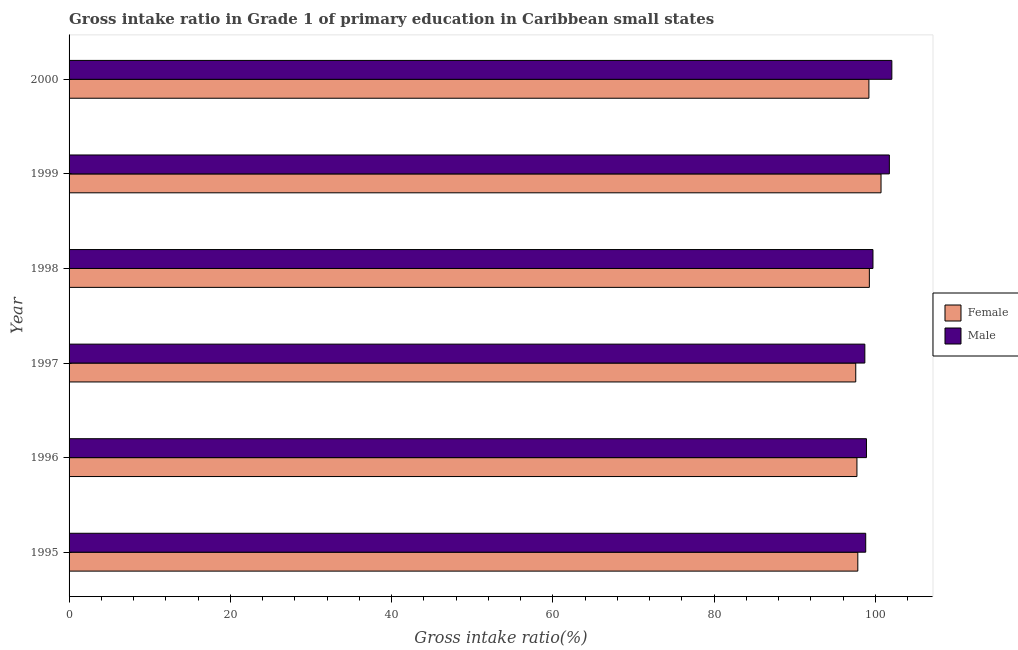How many different coloured bars are there?
Keep it short and to the point. 2. Are the number of bars per tick equal to the number of legend labels?
Ensure brevity in your answer.  Yes. Are the number of bars on each tick of the Y-axis equal?
Ensure brevity in your answer.  Yes. How many bars are there on the 4th tick from the bottom?
Keep it short and to the point. 2. What is the gross intake ratio(female) in 1999?
Make the answer very short. 100.7. Across all years, what is the maximum gross intake ratio(female)?
Your answer should be compact. 100.7. Across all years, what is the minimum gross intake ratio(male)?
Keep it short and to the point. 98.69. What is the total gross intake ratio(female) in the graph?
Make the answer very short. 592.22. What is the difference between the gross intake ratio(female) in 1995 and that in 1999?
Provide a short and direct response. -2.88. What is the difference between the gross intake ratio(female) in 2000 and the gross intake ratio(male) in 1996?
Your answer should be compact. 0.3. What is the average gross intake ratio(male) per year?
Offer a terse response. 99.97. In the year 1999, what is the difference between the gross intake ratio(male) and gross intake ratio(female)?
Make the answer very short. 1.03. What is the ratio of the gross intake ratio(female) in 1996 to that in 2000?
Offer a terse response. 0.98. Is the gross intake ratio(male) in 1995 less than that in 2000?
Offer a very short reply. Yes. Is the difference between the gross intake ratio(female) in 1995 and 1999 greater than the difference between the gross intake ratio(male) in 1995 and 1999?
Provide a succinct answer. Yes. What is the difference between the highest and the second highest gross intake ratio(female)?
Your answer should be compact. 1.45. What is the difference between the highest and the lowest gross intake ratio(female)?
Your answer should be compact. 3.14. In how many years, is the gross intake ratio(female) greater than the average gross intake ratio(female) taken over all years?
Make the answer very short. 3. What does the 2nd bar from the top in 2000 represents?
Your answer should be compact. Female. How many years are there in the graph?
Offer a terse response. 6. What is the difference between two consecutive major ticks on the X-axis?
Offer a very short reply. 20. Does the graph contain any zero values?
Ensure brevity in your answer.  No. Does the graph contain grids?
Provide a succinct answer. No. How are the legend labels stacked?
Offer a very short reply. Vertical. What is the title of the graph?
Provide a short and direct response. Gross intake ratio in Grade 1 of primary education in Caribbean small states. Does "Arms imports" appear as one of the legend labels in the graph?
Offer a very short reply. No. What is the label or title of the X-axis?
Give a very brief answer. Gross intake ratio(%). What is the Gross intake ratio(%) in Female in 1995?
Offer a terse response. 97.82. What is the Gross intake ratio(%) of Male in 1995?
Keep it short and to the point. 98.8. What is the Gross intake ratio(%) of Female in 1996?
Provide a succinct answer. 97.71. What is the Gross intake ratio(%) of Male in 1996?
Give a very brief answer. 98.89. What is the Gross intake ratio(%) of Female in 1997?
Give a very brief answer. 97.56. What is the Gross intake ratio(%) in Male in 1997?
Give a very brief answer. 98.69. What is the Gross intake ratio(%) in Female in 1998?
Keep it short and to the point. 99.25. What is the Gross intake ratio(%) of Male in 1998?
Offer a very short reply. 99.7. What is the Gross intake ratio(%) in Female in 1999?
Offer a terse response. 100.7. What is the Gross intake ratio(%) in Male in 1999?
Offer a very short reply. 101.73. What is the Gross intake ratio(%) of Female in 2000?
Offer a terse response. 99.19. What is the Gross intake ratio(%) of Male in 2000?
Your answer should be compact. 102.04. Across all years, what is the maximum Gross intake ratio(%) of Female?
Your answer should be compact. 100.7. Across all years, what is the maximum Gross intake ratio(%) of Male?
Offer a very short reply. 102.04. Across all years, what is the minimum Gross intake ratio(%) in Female?
Ensure brevity in your answer.  97.56. Across all years, what is the minimum Gross intake ratio(%) in Male?
Offer a very short reply. 98.69. What is the total Gross intake ratio(%) of Female in the graph?
Offer a very short reply. 592.22. What is the total Gross intake ratio(%) in Male in the graph?
Provide a short and direct response. 599.83. What is the difference between the Gross intake ratio(%) of Female in 1995 and that in 1996?
Ensure brevity in your answer.  0.11. What is the difference between the Gross intake ratio(%) in Male in 1995 and that in 1996?
Give a very brief answer. -0.09. What is the difference between the Gross intake ratio(%) of Female in 1995 and that in 1997?
Make the answer very short. 0.26. What is the difference between the Gross intake ratio(%) in Male in 1995 and that in 1997?
Offer a terse response. 0.11. What is the difference between the Gross intake ratio(%) in Female in 1995 and that in 1998?
Ensure brevity in your answer.  -1.43. What is the difference between the Gross intake ratio(%) of Male in 1995 and that in 1998?
Make the answer very short. -0.9. What is the difference between the Gross intake ratio(%) in Female in 1995 and that in 1999?
Make the answer very short. -2.88. What is the difference between the Gross intake ratio(%) in Male in 1995 and that in 1999?
Your answer should be very brief. -2.93. What is the difference between the Gross intake ratio(%) of Female in 1995 and that in 2000?
Ensure brevity in your answer.  -1.38. What is the difference between the Gross intake ratio(%) in Male in 1995 and that in 2000?
Keep it short and to the point. -3.24. What is the difference between the Gross intake ratio(%) in Female in 1996 and that in 1997?
Offer a terse response. 0.15. What is the difference between the Gross intake ratio(%) of Male in 1996 and that in 1997?
Ensure brevity in your answer.  0.2. What is the difference between the Gross intake ratio(%) of Female in 1996 and that in 1998?
Your response must be concise. -1.54. What is the difference between the Gross intake ratio(%) of Male in 1996 and that in 1998?
Provide a succinct answer. -0.81. What is the difference between the Gross intake ratio(%) of Female in 1996 and that in 1999?
Make the answer very short. -2.99. What is the difference between the Gross intake ratio(%) in Male in 1996 and that in 1999?
Your answer should be compact. -2.84. What is the difference between the Gross intake ratio(%) of Female in 1996 and that in 2000?
Your answer should be very brief. -1.48. What is the difference between the Gross intake ratio(%) of Male in 1996 and that in 2000?
Provide a short and direct response. -3.15. What is the difference between the Gross intake ratio(%) of Female in 1997 and that in 1998?
Give a very brief answer. -1.69. What is the difference between the Gross intake ratio(%) of Male in 1997 and that in 1998?
Your answer should be very brief. -1.01. What is the difference between the Gross intake ratio(%) of Female in 1997 and that in 1999?
Provide a succinct answer. -3.14. What is the difference between the Gross intake ratio(%) of Male in 1997 and that in 1999?
Offer a terse response. -3.04. What is the difference between the Gross intake ratio(%) of Female in 1997 and that in 2000?
Your answer should be compact. -1.63. What is the difference between the Gross intake ratio(%) in Male in 1997 and that in 2000?
Your answer should be compact. -3.35. What is the difference between the Gross intake ratio(%) in Female in 1998 and that in 1999?
Keep it short and to the point. -1.45. What is the difference between the Gross intake ratio(%) in Male in 1998 and that in 1999?
Provide a succinct answer. -2.03. What is the difference between the Gross intake ratio(%) in Female in 1998 and that in 2000?
Make the answer very short. 0.06. What is the difference between the Gross intake ratio(%) of Male in 1998 and that in 2000?
Make the answer very short. -2.34. What is the difference between the Gross intake ratio(%) of Female in 1999 and that in 2000?
Make the answer very short. 1.5. What is the difference between the Gross intake ratio(%) in Male in 1999 and that in 2000?
Provide a short and direct response. -0.31. What is the difference between the Gross intake ratio(%) of Female in 1995 and the Gross intake ratio(%) of Male in 1996?
Provide a succinct answer. -1.07. What is the difference between the Gross intake ratio(%) of Female in 1995 and the Gross intake ratio(%) of Male in 1997?
Your answer should be compact. -0.87. What is the difference between the Gross intake ratio(%) of Female in 1995 and the Gross intake ratio(%) of Male in 1998?
Make the answer very short. -1.88. What is the difference between the Gross intake ratio(%) in Female in 1995 and the Gross intake ratio(%) in Male in 1999?
Offer a very short reply. -3.91. What is the difference between the Gross intake ratio(%) of Female in 1995 and the Gross intake ratio(%) of Male in 2000?
Provide a succinct answer. -4.22. What is the difference between the Gross intake ratio(%) in Female in 1996 and the Gross intake ratio(%) in Male in 1997?
Keep it short and to the point. -0.98. What is the difference between the Gross intake ratio(%) in Female in 1996 and the Gross intake ratio(%) in Male in 1998?
Make the answer very short. -1.99. What is the difference between the Gross intake ratio(%) of Female in 1996 and the Gross intake ratio(%) of Male in 1999?
Your response must be concise. -4.02. What is the difference between the Gross intake ratio(%) in Female in 1996 and the Gross intake ratio(%) in Male in 2000?
Offer a terse response. -4.33. What is the difference between the Gross intake ratio(%) in Female in 1997 and the Gross intake ratio(%) in Male in 1998?
Offer a terse response. -2.14. What is the difference between the Gross intake ratio(%) of Female in 1997 and the Gross intake ratio(%) of Male in 1999?
Provide a short and direct response. -4.17. What is the difference between the Gross intake ratio(%) of Female in 1997 and the Gross intake ratio(%) of Male in 2000?
Ensure brevity in your answer.  -4.48. What is the difference between the Gross intake ratio(%) in Female in 1998 and the Gross intake ratio(%) in Male in 1999?
Give a very brief answer. -2.48. What is the difference between the Gross intake ratio(%) of Female in 1998 and the Gross intake ratio(%) of Male in 2000?
Offer a very short reply. -2.79. What is the difference between the Gross intake ratio(%) of Female in 1999 and the Gross intake ratio(%) of Male in 2000?
Offer a terse response. -1.34. What is the average Gross intake ratio(%) of Female per year?
Your response must be concise. 98.7. What is the average Gross intake ratio(%) of Male per year?
Your answer should be very brief. 99.97. In the year 1995, what is the difference between the Gross intake ratio(%) in Female and Gross intake ratio(%) in Male?
Ensure brevity in your answer.  -0.98. In the year 1996, what is the difference between the Gross intake ratio(%) of Female and Gross intake ratio(%) of Male?
Give a very brief answer. -1.18. In the year 1997, what is the difference between the Gross intake ratio(%) in Female and Gross intake ratio(%) in Male?
Ensure brevity in your answer.  -1.13. In the year 1998, what is the difference between the Gross intake ratio(%) in Female and Gross intake ratio(%) in Male?
Your answer should be very brief. -0.45. In the year 1999, what is the difference between the Gross intake ratio(%) of Female and Gross intake ratio(%) of Male?
Offer a very short reply. -1.03. In the year 2000, what is the difference between the Gross intake ratio(%) of Female and Gross intake ratio(%) of Male?
Offer a very short reply. -2.84. What is the ratio of the Gross intake ratio(%) of Male in 1995 to that in 1997?
Your response must be concise. 1. What is the ratio of the Gross intake ratio(%) of Female in 1995 to that in 1998?
Make the answer very short. 0.99. What is the ratio of the Gross intake ratio(%) of Female in 1995 to that in 1999?
Your response must be concise. 0.97. What is the ratio of the Gross intake ratio(%) in Male in 1995 to that in 1999?
Your answer should be compact. 0.97. What is the ratio of the Gross intake ratio(%) of Female in 1995 to that in 2000?
Your answer should be compact. 0.99. What is the ratio of the Gross intake ratio(%) of Male in 1995 to that in 2000?
Make the answer very short. 0.97. What is the ratio of the Gross intake ratio(%) in Male in 1996 to that in 1997?
Provide a succinct answer. 1. What is the ratio of the Gross intake ratio(%) of Female in 1996 to that in 1998?
Your answer should be compact. 0.98. What is the ratio of the Gross intake ratio(%) of Female in 1996 to that in 1999?
Give a very brief answer. 0.97. What is the ratio of the Gross intake ratio(%) in Male in 1996 to that in 1999?
Your answer should be very brief. 0.97. What is the ratio of the Gross intake ratio(%) of Female in 1996 to that in 2000?
Your answer should be compact. 0.98. What is the ratio of the Gross intake ratio(%) in Male in 1996 to that in 2000?
Offer a very short reply. 0.97. What is the ratio of the Gross intake ratio(%) in Female in 1997 to that in 1998?
Keep it short and to the point. 0.98. What is the ratio of the Gross intake ratio(%) in Male in 1997 to that in 1998?
Give a very brief answer. 0.99. What is the ratio of the Gross intake ratio(%) of Female in 1997 to that in 1999?
Provide a short and direct response. 0.97. What is the ratio of the Gross intake ratio(%) of Male in 1997 to that in 1999?
Make the answer very short. 0.97. What is the ratio of the Gross intake ratio(%) of Female in 1997 to that in 2000?
Offer a very short reply. 0.98. What is the ratio of the Gross intake ratio(%) in Male in 1997 to that in 2000?
Provide a succinct answer. 0.97. What is the ratio of the Gross intake ratio(%) of Female in 1998 to that in 1999?
Give a very brief answer. 0.99. What is the ratio of the Gross intake ratio(%) of Male in 1998 to that in 1999?
Provide a short and direct response. 0.98. What is the ratio of the Gross intake ratio(%) of Female in 1998 to that in 2000?
Your answer should be compact. 1. What is the ratio of the Gross intake ratio(%) in Male in 1998 to that in 2000?
Your response must be concise. 0.98. What is the ratio of the Gross intake ratio(%) of Female in 1999 to that in 2000?
Offer a very short reply. 1.02. What is the difference between the highest and the second highest Gross intake ratio(%) of Female?
Ensure brevity in your answer.  1.45. What is the difference between the highest and the second highest Gross intake ratio(%) in Male?
Your answer should be very brief. 0.31. What is the difference between the highest and the lowest Gross intake ratio(%) of Female?
Make the answer very short. 3.14. What is the difference between the highest and the lowest Gross intake ratio(%) of Male?
Provide a succinct answer. 3.35. 